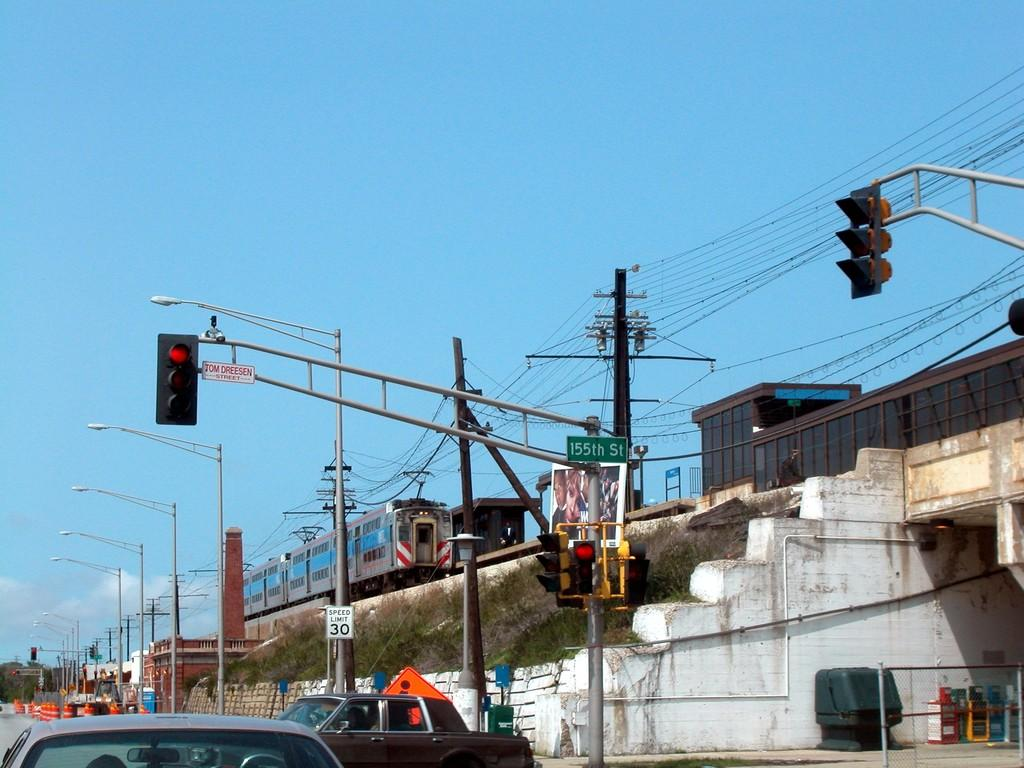What types of transportation are present in the image? There are vehicles and a train in the image. What structures are present to help regulate traffic? There are light poles and traffic signals in the image. What color is the sky in the background of the image? The sky is blue in the background of the image. Can you see any balloons floating in the sky in the image? There are no balloons visible in the image; the sky is blue in the background. What type of eye is present in the image? There is no eye present in the image; it features vehicles, a train, light poles, traffic signals, and a blue sky. 